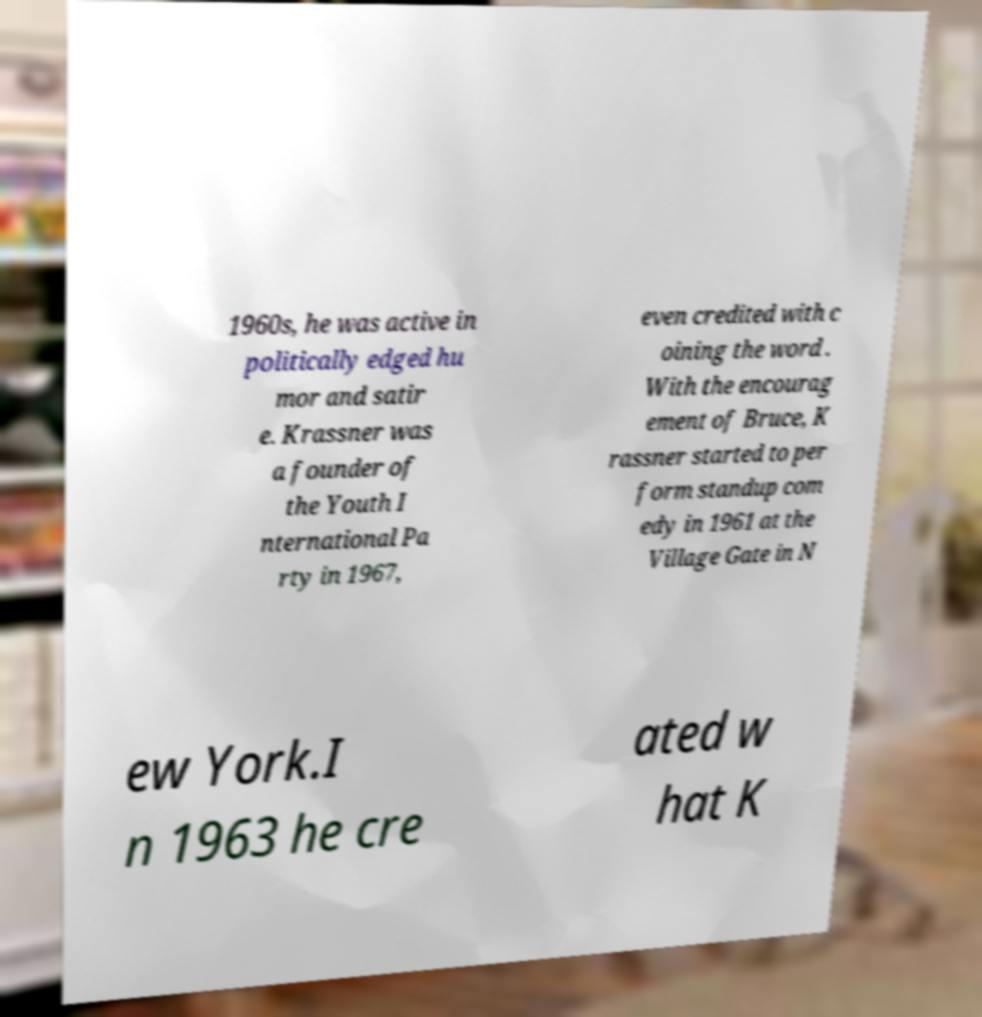Can you accurately transcribe the text from the provided image for me? 1960s, he was active in politically edged hu mor and satir e. Krassner was a founder of the Youth I nternational Pa rty in 1967, even credited with c oining the word . With the encourag ement of Bruce, K rassner started to per form standup com edy in 1961 at the Village Gate in N ew York.I n 1963 he cre ated w hat K 